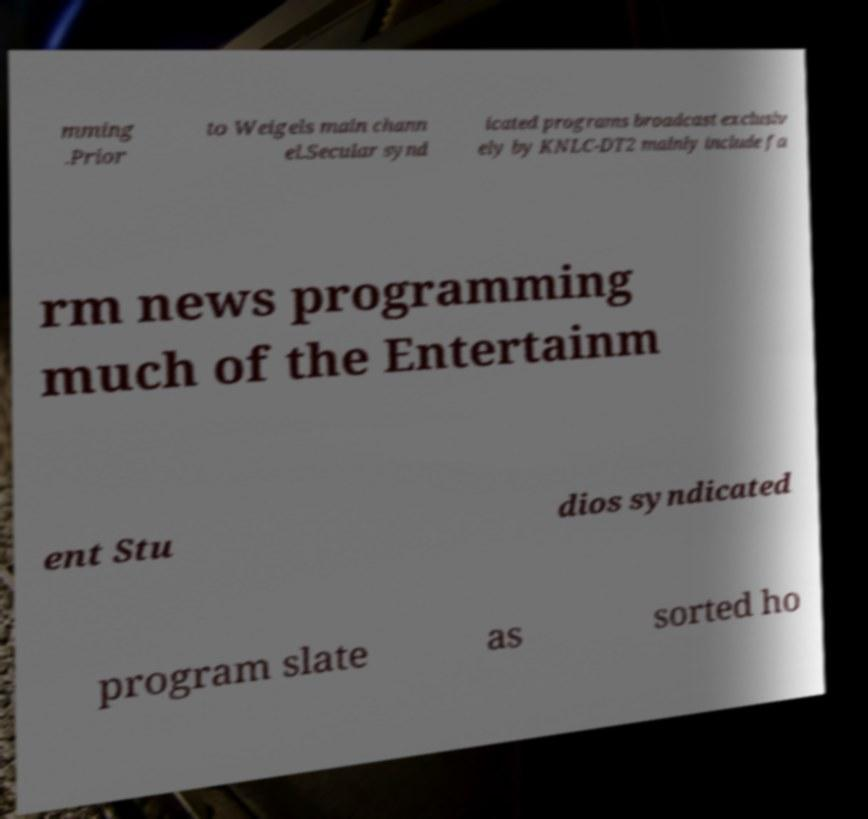Could you assist in decoding the text presented in this image and type it out clearly? mming .Prior to Weigels main chann el.Secular synd icated programs broadcast exclusiv ely by KNLC-DT2 mainly include fa rm news programming much of the Entertainm ent Stu dios syndicated program slate as sorted ho 